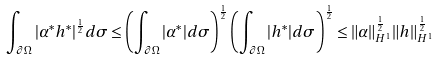<formula> <loc_0><loc_0><loc_500><loc_500>\int _ { \partial \Omega } | \alpha ^ { * } h ^ { * } | ^ { \frac { 1 } { 2 } } d \sigma \leq \left ( \int _ { \partial \Omega } | \alpha ^ { * } | d \sigma \right ) ^ { \frac { 1 } { 2 } } \left ( \int _ { \partial \Omega } | h ^ { * } | d \sigma \right ) ^ { \frac { 1 } { 2 } } \leq \| \alpha \| _ { H ^ { 1 } } ^ { \frac { 1 } { 2 } } \| h \| _ { H ^ { 1 } } ^ { \frac { 1 } { 2 } }</formula> 